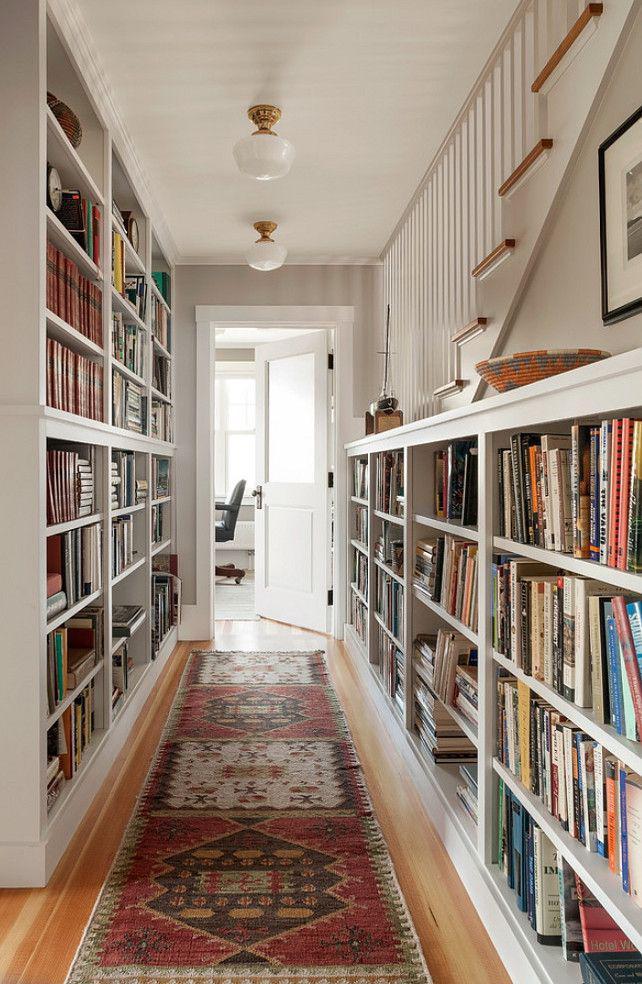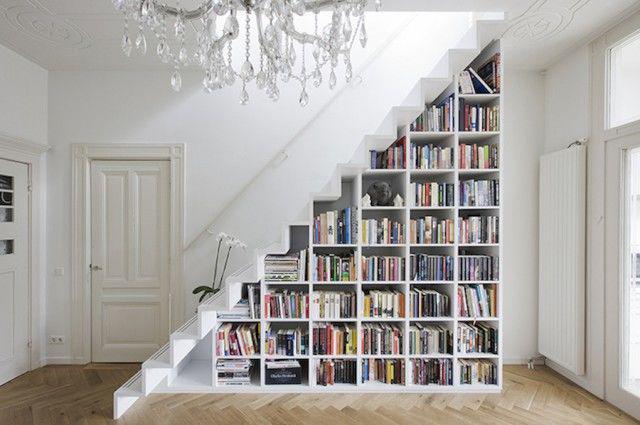The first image is the image on the left, the second image is the image on the right. For the images shown, is this caption "One image shows bookcases lining the left and right walls, with a floor between." true? Answer yes or no. Yes. The first image is the image on the left, the second image is the image on the right. Examine the images to the left and right. Is the description "In one image, white bookshelves run parallel on opposing walls." accurate? Answer yes or no. Yes. 